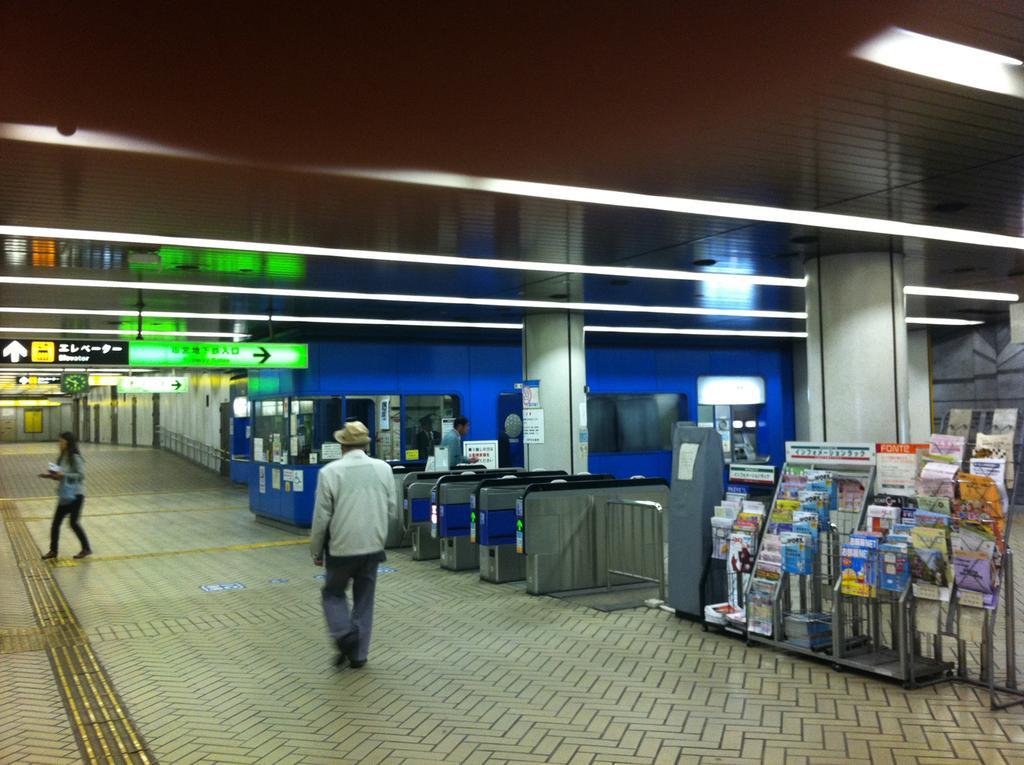How would you summarize this image in a sentence or two? Here two people are walking, there are books in the shelf. 